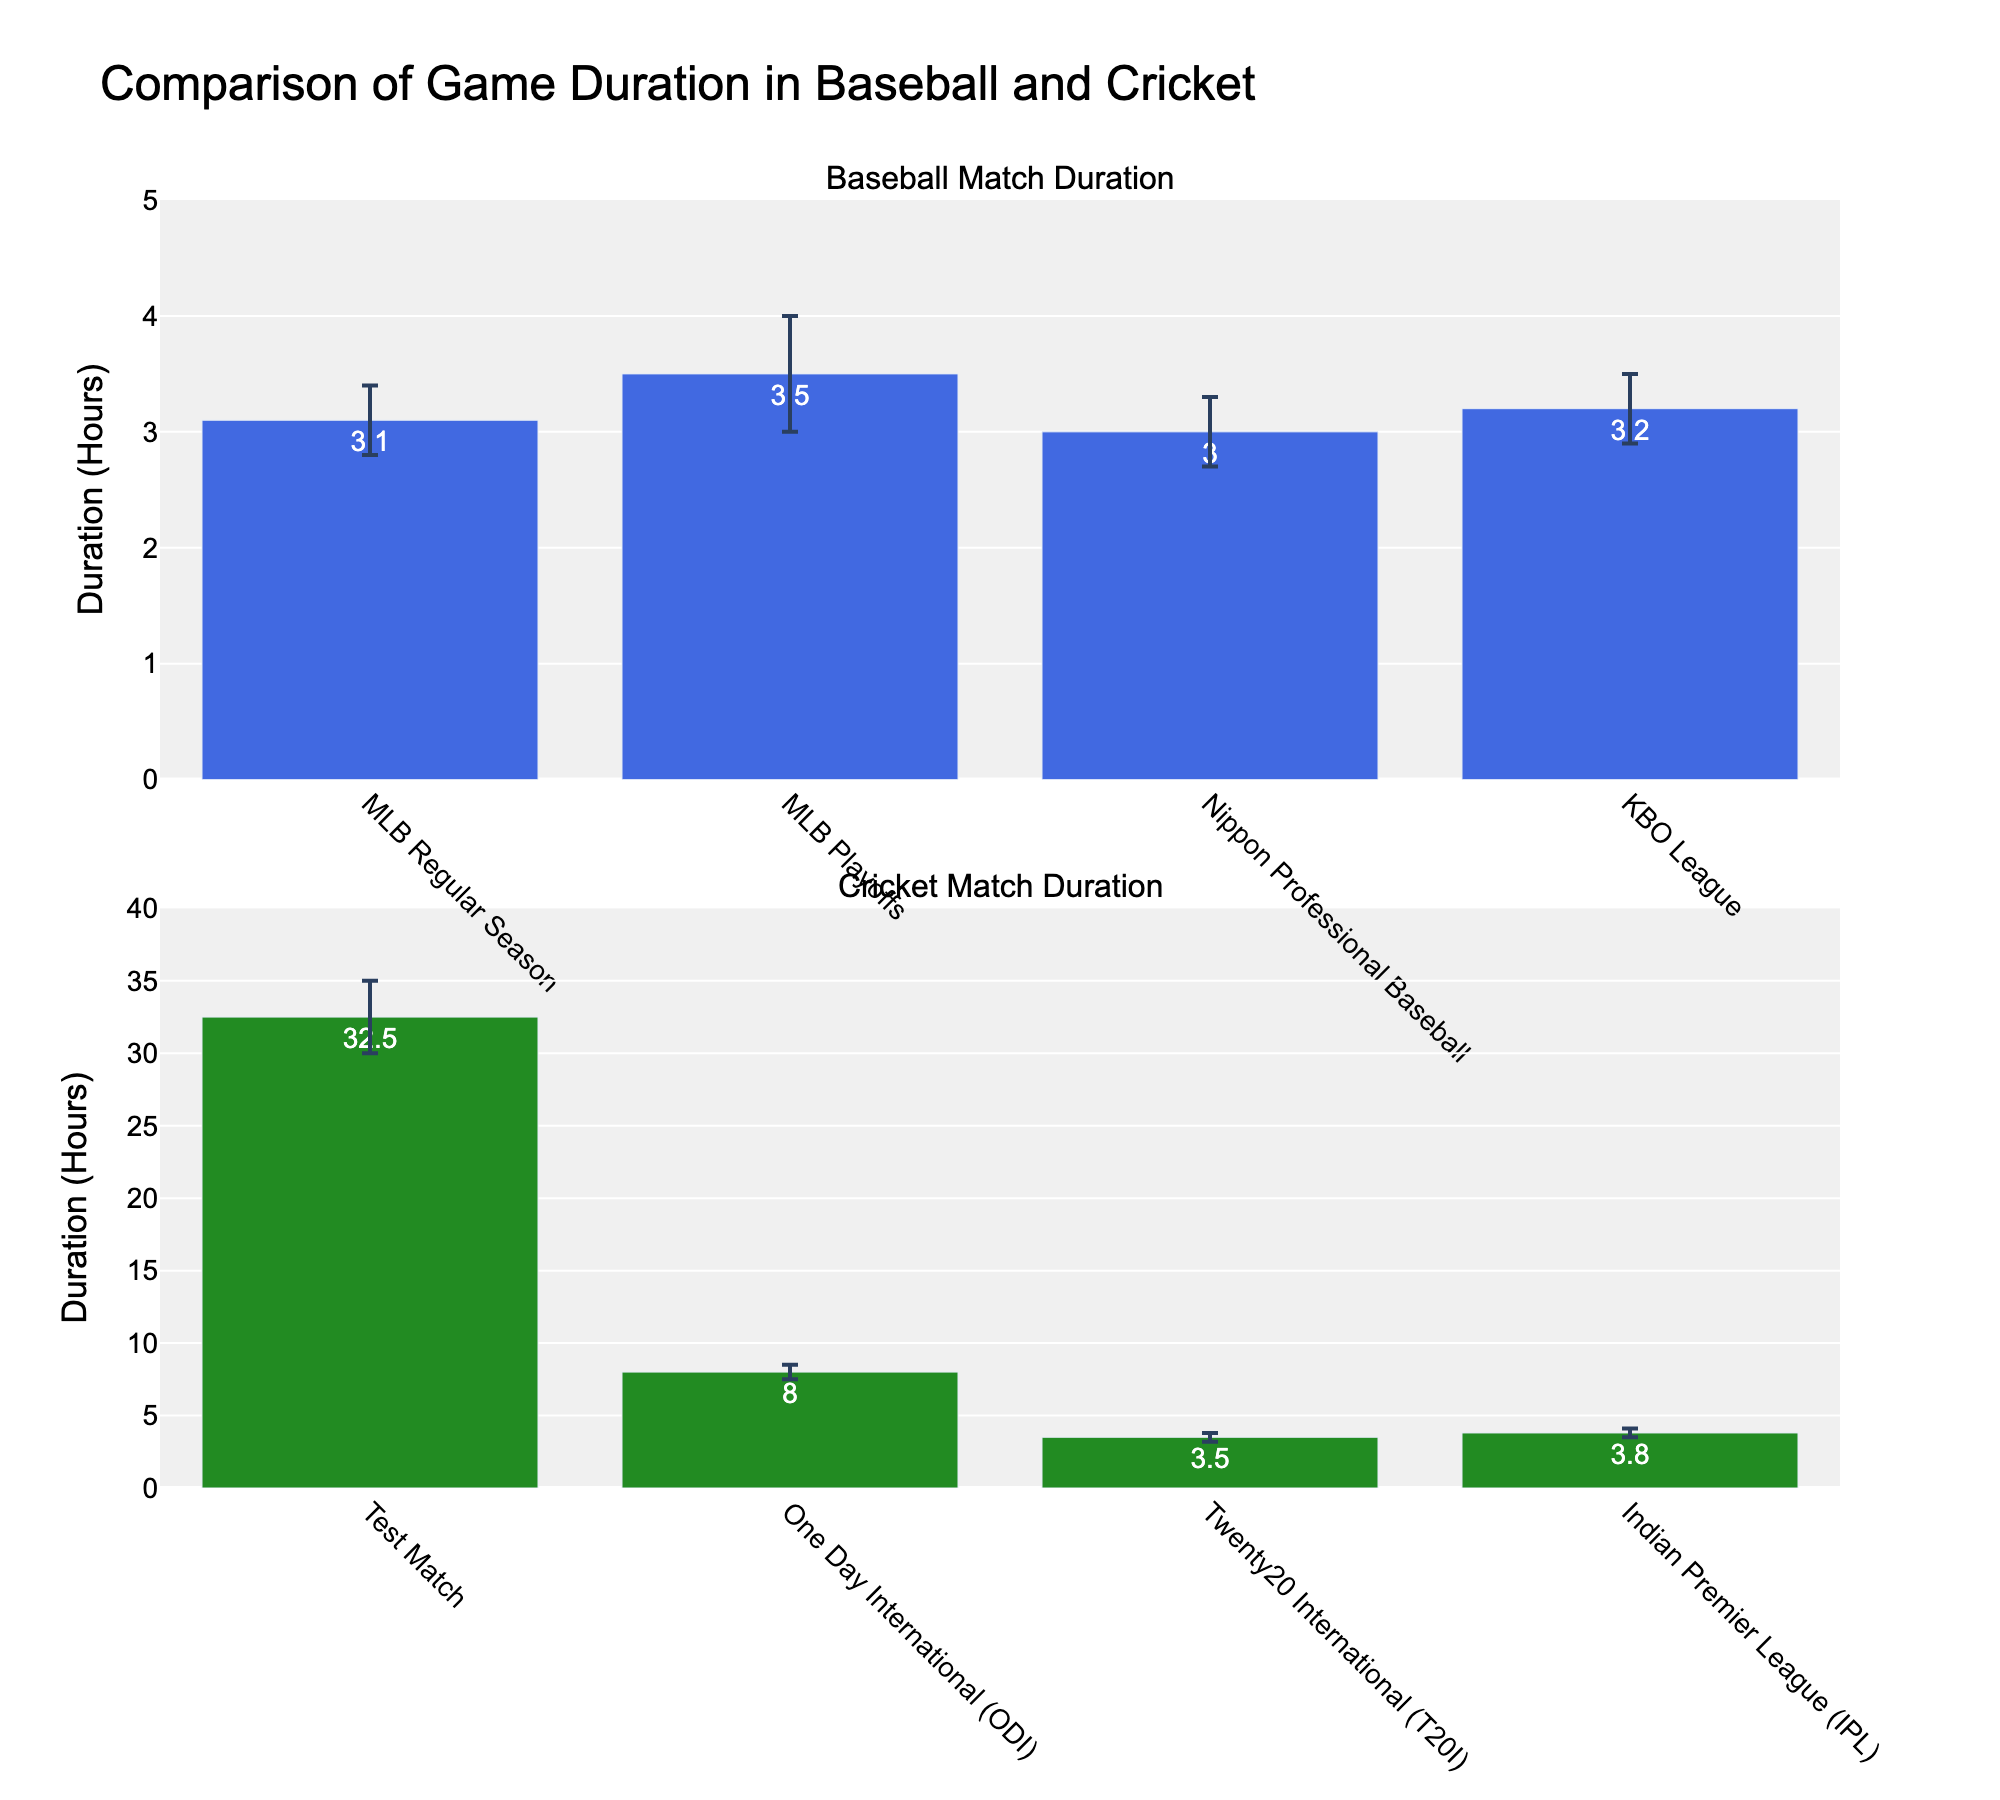Which type of cricket match has the longest average duration? The longest average duration for a cricket match can be identified by looking at the cricket subplot and finding the bar with the highest value. The Test Match has the highest value at 32.5 hours.
Answer: Test Match What is the duration range for MLB Playoffs? The duration range can be determined by subtracting the lower confidence interval from the upper confidence interval for the MLB Playoffs. The range is 4.0 - 3.0 = 1.0 hours.
Answer: 1.0 hours How does the duration of T20I compare to IPL in cricket? Compare the heights of the bars representing T20I and IPL in the cricket subplot. T20I has an average duration of 3.5 hours while IPL has a duration of 3.8 hours, making IPL slightly longer.
Answer: IPL is longer Which baseball match type has the shortest lower confidence interval? To find this, compare the lower confidence intervals of all baseball match types. Nippon Professional Baseball has the shortest lower confidence interval at 2.7 hours.
Answer: Nippon Professional Baseball What is the average game duration of MLB Regular Season and KBO League combined? Sum the average durations of MLB Regular Season (3.1 hours) and KBO League (3.2 hours), then divide by 2. (3.1 + 3.2) / 2 = 3.15 hours.
Answer: 3.15 hours Which cricket match type has the smallest error range? To find the smallest error range, compare the difference between upper and lower confidence intervals for all cricket matches. T20I has the smallest error range of 3.8 - 3.2 = 0.6 hours.
Answer: T20I Is the average game duration for Major League Baseball Regular Season longer than Twenty20 International? Compare the average durations for MLB Regular Season (3.1 hours) and T20I (3.5 hours). T20I is longer.
Answer: No What is the upper confidence interval of One Day International (ODI) matches? The upper confidence interval for One Day International can be read directly from the cricket subplot, which is 8.5 hours.
Answer: 8.5 hours How many cricket match types have an average duration longer than 4 hours? From the cricket subplot, identify the match types with bars exceeding 4 hours. Only the Test Match (32.5 hours) and ODI (8.0 hours) are longer than 4 hours.
Answer: Two 